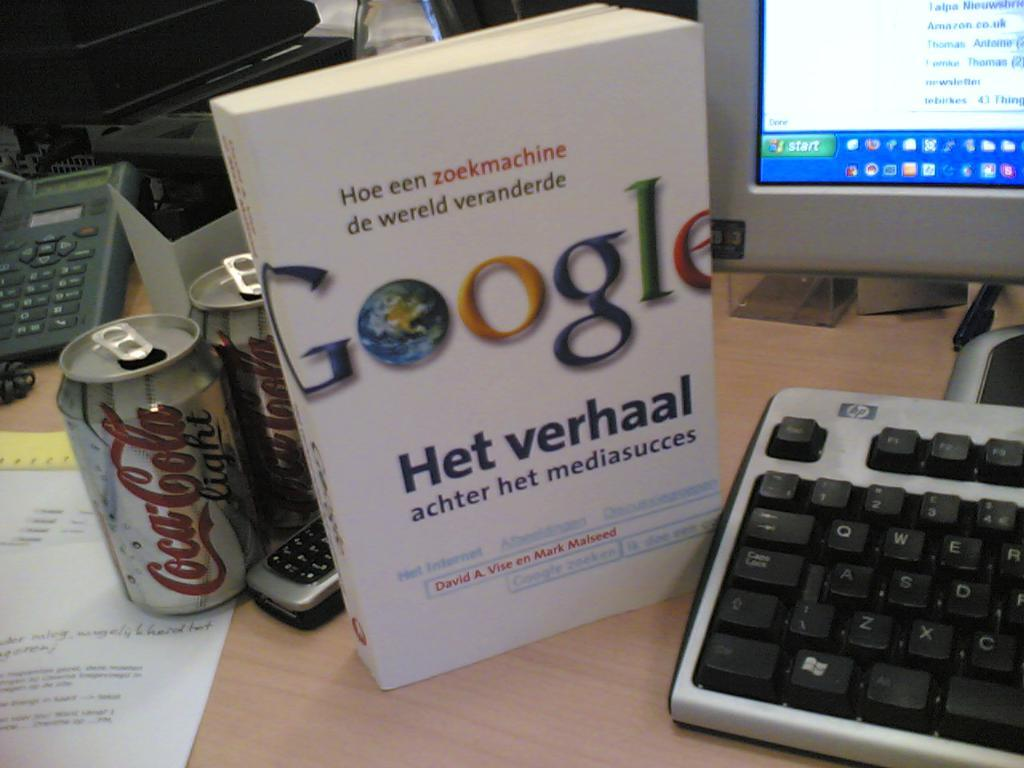<image>
Present a compact description of the photo's key features. a book called GOOGLE Het Verhal sits on a desk 